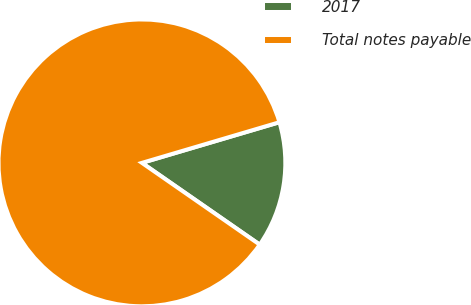<chart> <loc_0><loc_0><loc_500><loc_500><pie_chart><fcel>2017<fcel>Total notes payable<nl><fcel>14.23%<fcel>85.77%<nl></chart> 